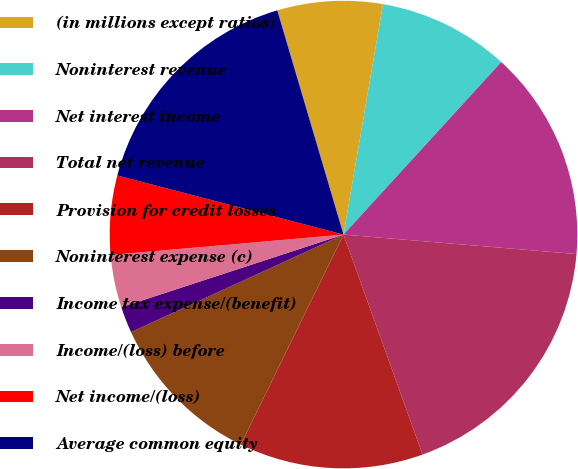Convert chart to OTSL. <chart><loc_0><loc_0><loc_500><loc_500><pie_chart><fcel>(in millions except ratios)<fcel>Noninterest revenue<fcel>Net interest income<fcel>Total net revenue<fcel>Provision for credit losses<fcel>Noninterest expense (c)<fcel>Income tax expense/(benefit)<fcel>Income/(loss) before<fcel>Net income/(loss)<fcel>Average common equity<nl><fcel>7.27%<fcel>9.09%<fcel>14.54%<fcel>18.18%<fcel>12.73%<fcel>10.91%<fcel>1.82%<fcel>3.64%<fcel>5.46%<fcel>16.36%<nl></chart> 